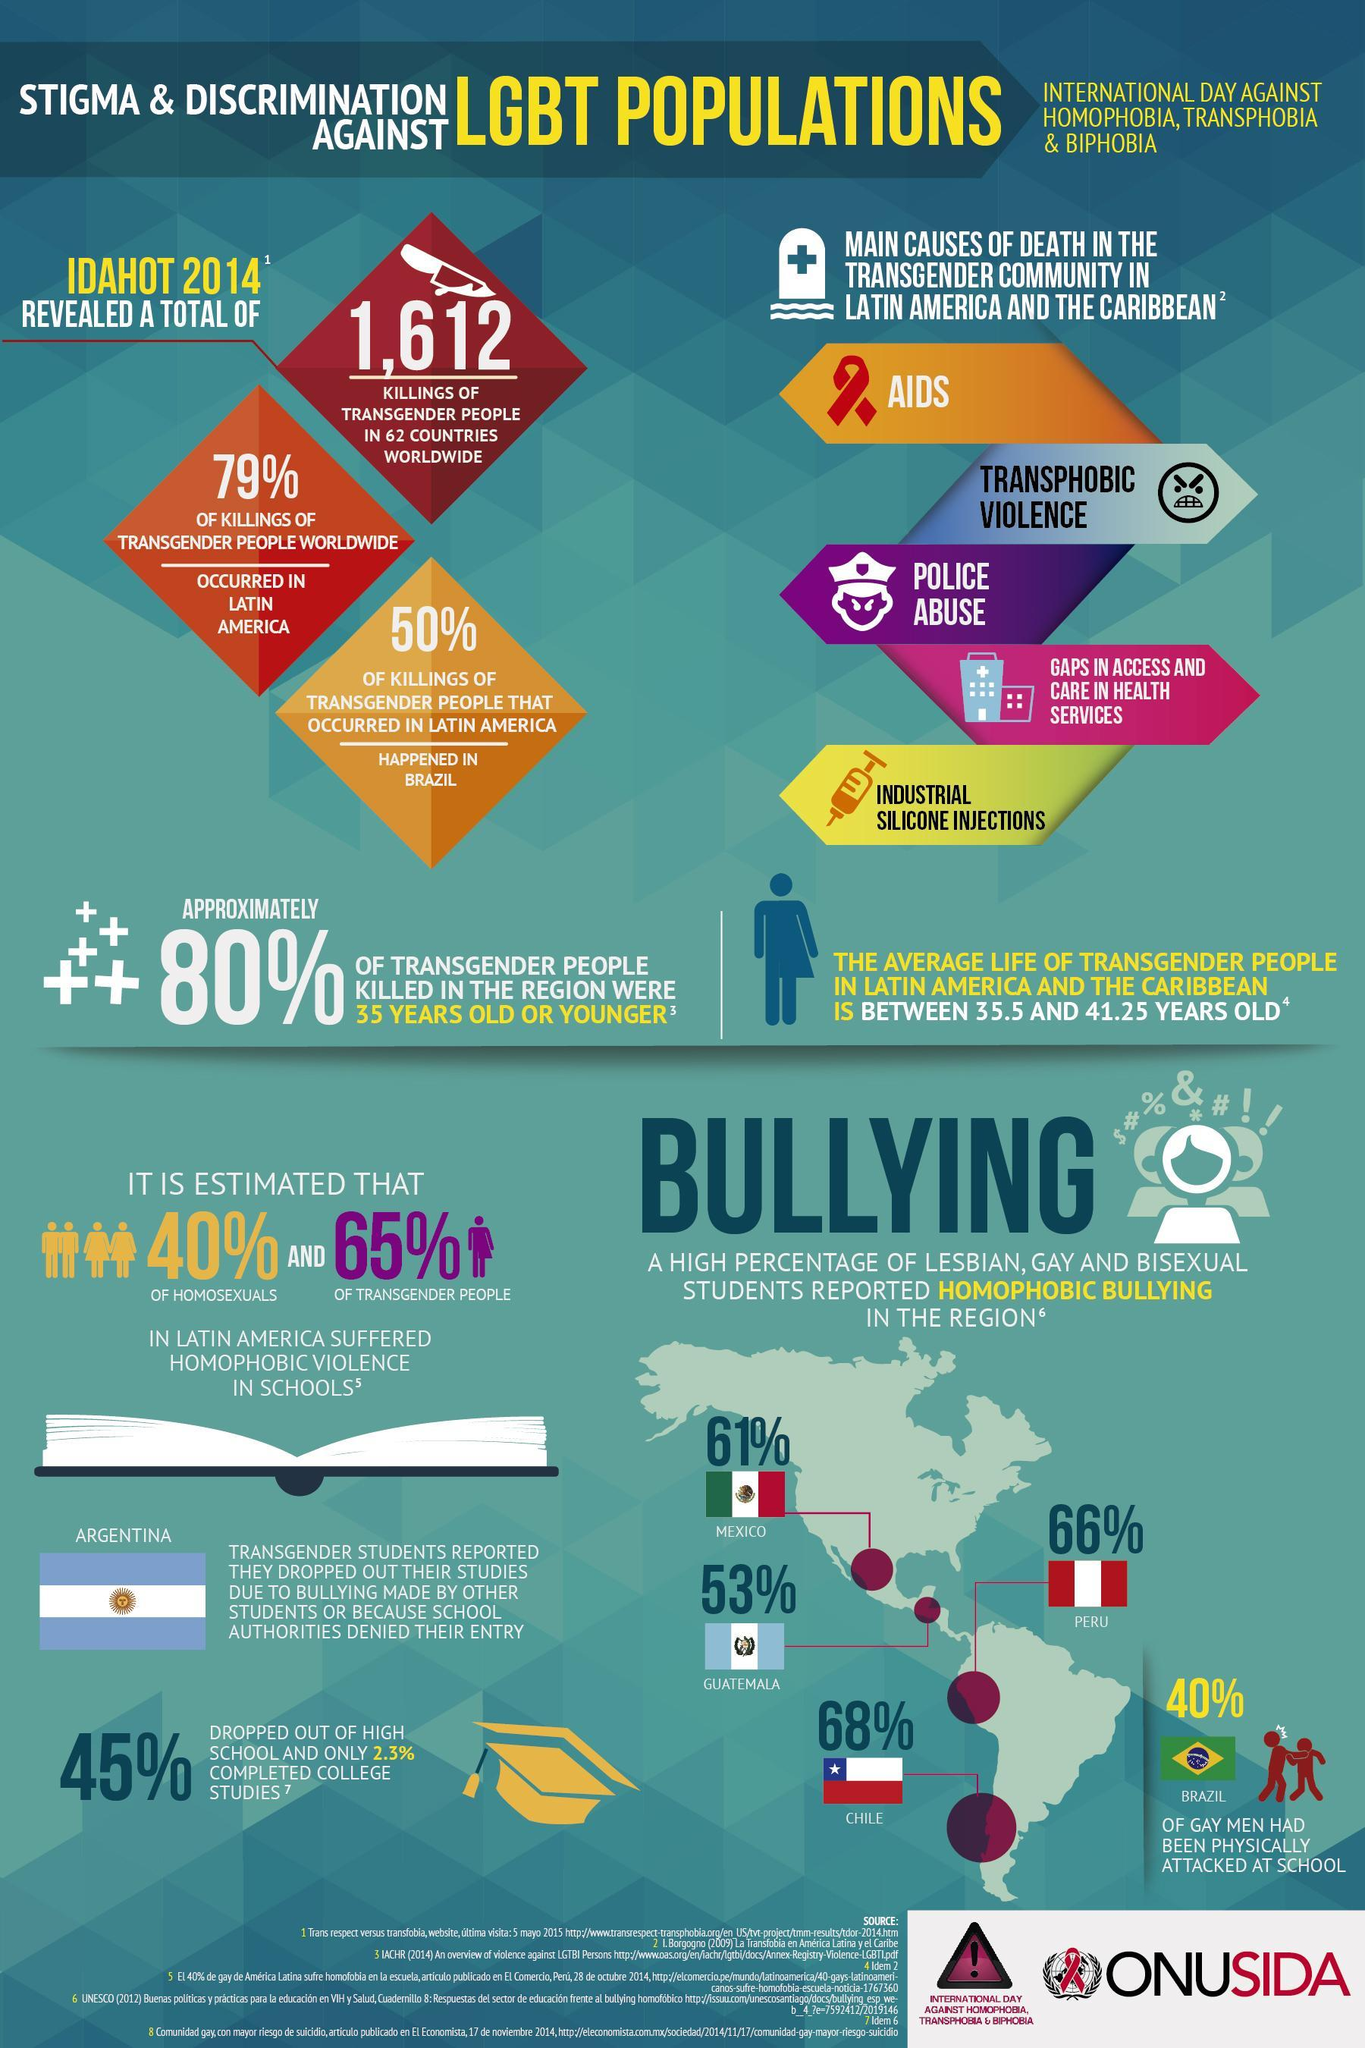What is listed third in the causes of death of transgenders?
Answer the question with a short phrase. Police abuse In which country was 66% of homophobic bullying reported? Peru What was the total number of killings reported globally? 1,612 In which Latin American country did the most killings occur? Brazil What was the percentage of homophobic bullying reported in Guatemala? 53% What is listed first in causes of death of transgenders? AIDS 